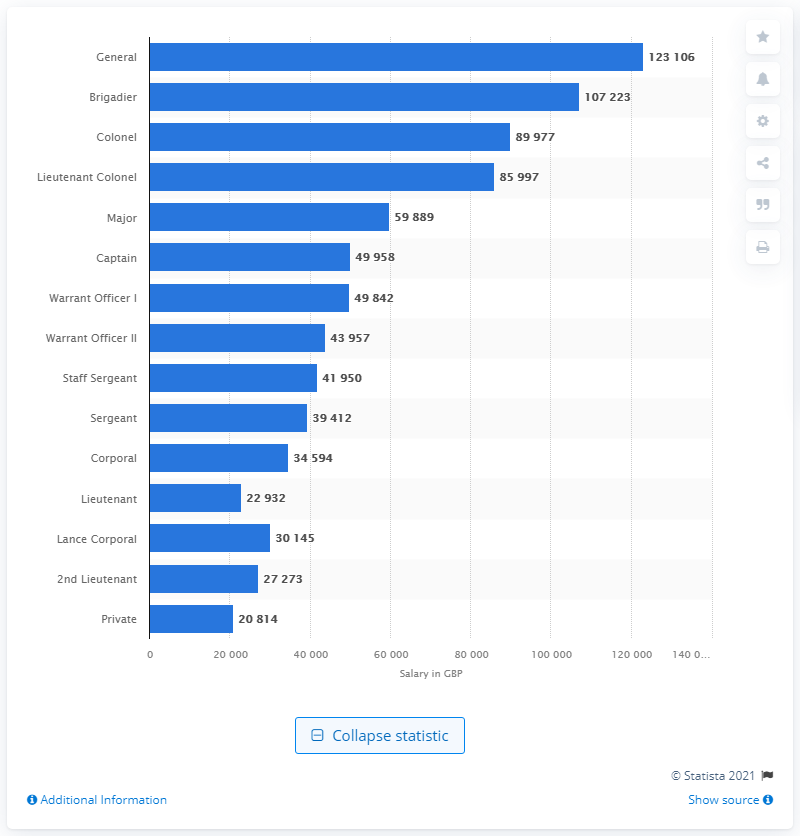Identify some key points in this picture. The average annual salary for the rank of General was 123,106. In the UK Armed Forces in the 2019/20 fiscal year, privates earned an average annual salary of 20,814 pounds. 